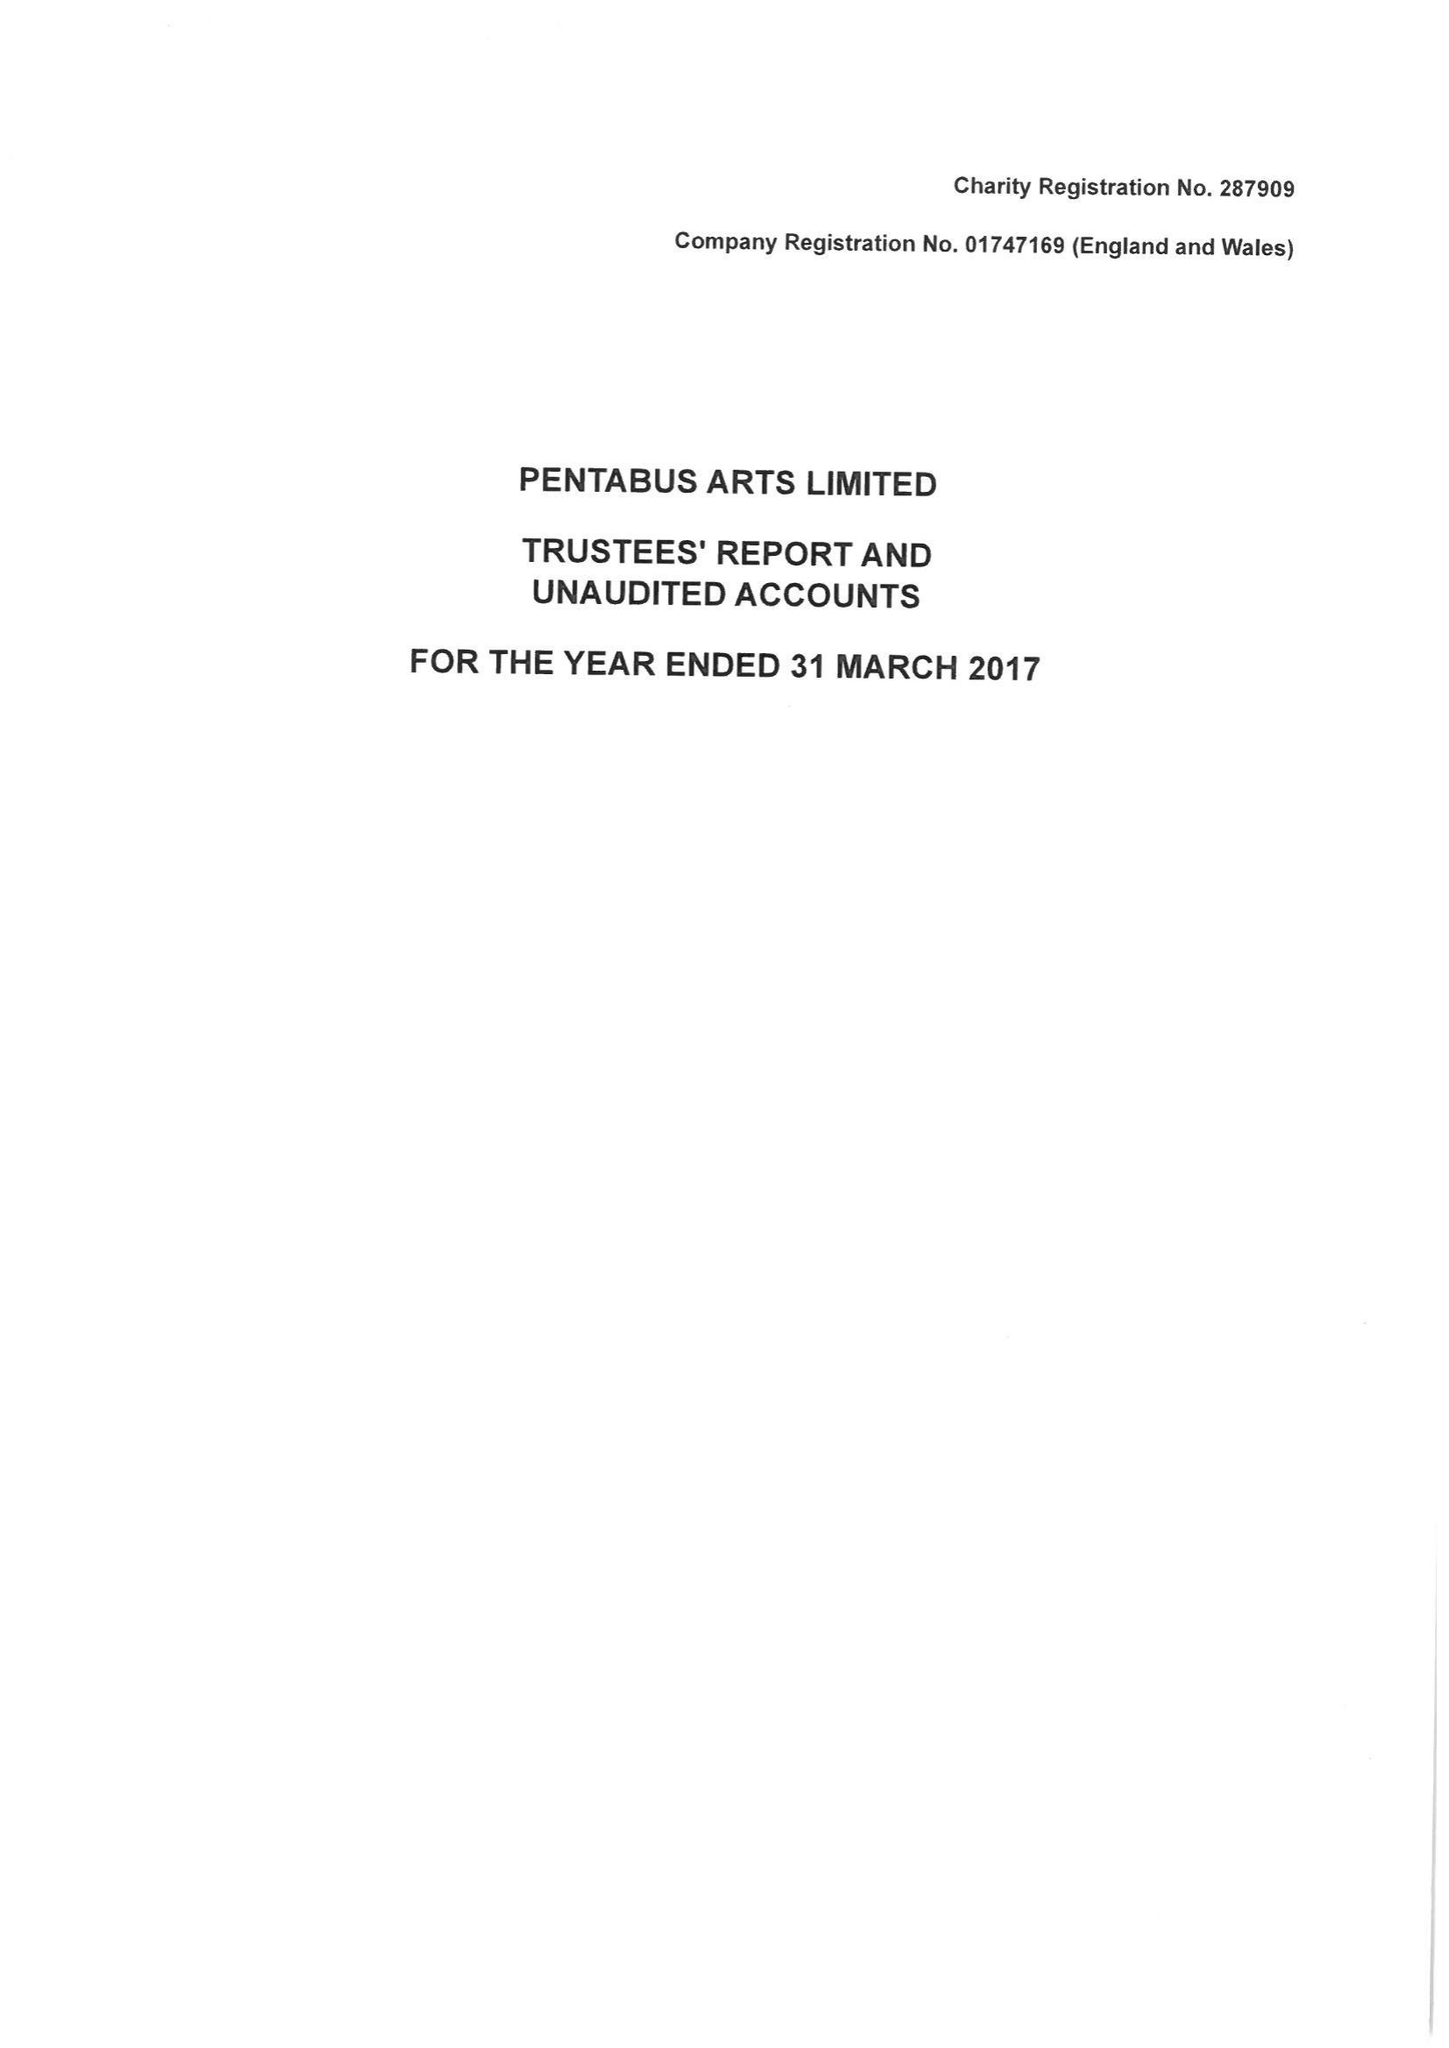What is the value for the report_date?
Answer the question using a single word or phrase. 2017-03-31 